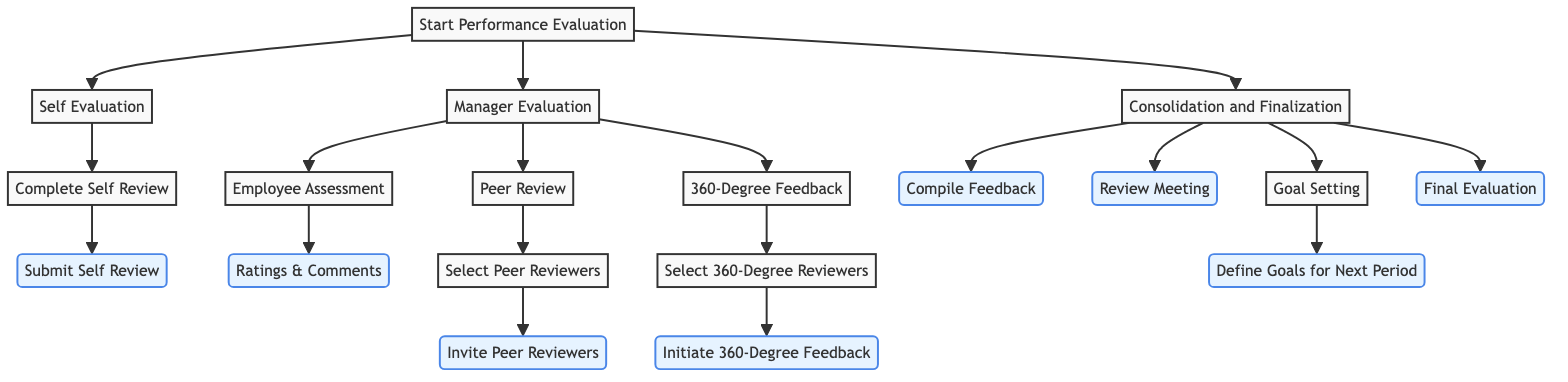What is the first step in the performance evaluation workflow? The diagram shows that the first step is "Start Performance Evaluation." This is the root node from which all other options branch out.
Answer: Start Performance Evaluation How many main options are presented in the performance evaluation process? The diagram indicates that there are three main options stemming from the root: "Self Evaluation," "Manager Evaluation," and "Consolidation and Finalization." This counts as three distinct paths.
Answer: 3 What is the outcome after submitting a self review? According to the diagram, the outcome after submitting the self review is "Manager Review," which directly follows the node "Submit Self Review."
Answer: Manager Review What are the final evaluation steps available after consolidation? The diagram reveals that the final evaluation steps include "Compile Feedback," "Review Meeting," "Goal Setting," and "Final Evaluation," marking four distinct outcomes from the consolidation process.
Answer: Compile Feedback, Review Meeting, Goal Setting, Final Evaluation Which option involves inviting peer reviewers? The diagram shows that inviting peer reviewers is featured under the "Peer Review" option. Specifically, it follows the steps of "Select Peer Reviewers" before leading to "Invite Peer Reviewers."
Answer: Invite Peer Reviewers What happens after initiating the 360-degree feedback? The outcome that follows the initiation of 360-degree feedback is "Collect 360-Degree Feedback." This relationship indicates the flow from the action of initiating to the result of collecting feedback.
Answer: Collect 360-Degree Feedback How many evaluation methods are listed under Manager Evaluation? The diagram illustrates three specific evaluation methods under Manager Evaluation: "Employee Assessment," "Peer Review," and "360-Degree Feedback." This quantifies to three methods.
Answer: 3 What is the next step after defining goals for the next period? The diagram indicates that after defining goals for the next period, the outcome is to "Set Action Plans," thus following the path beginning from "Goal Setting."
Answer: Set Action Plans What leads to collecting feedback in the peer review process? The diagram explains that selecting peer reviewers leads to inviting them, which is the step that results in "Collect Feedback." The flow shows a direct cause-effect relationship from selection to invitation and then to feedback collection.
Answer: Collect Feedback 